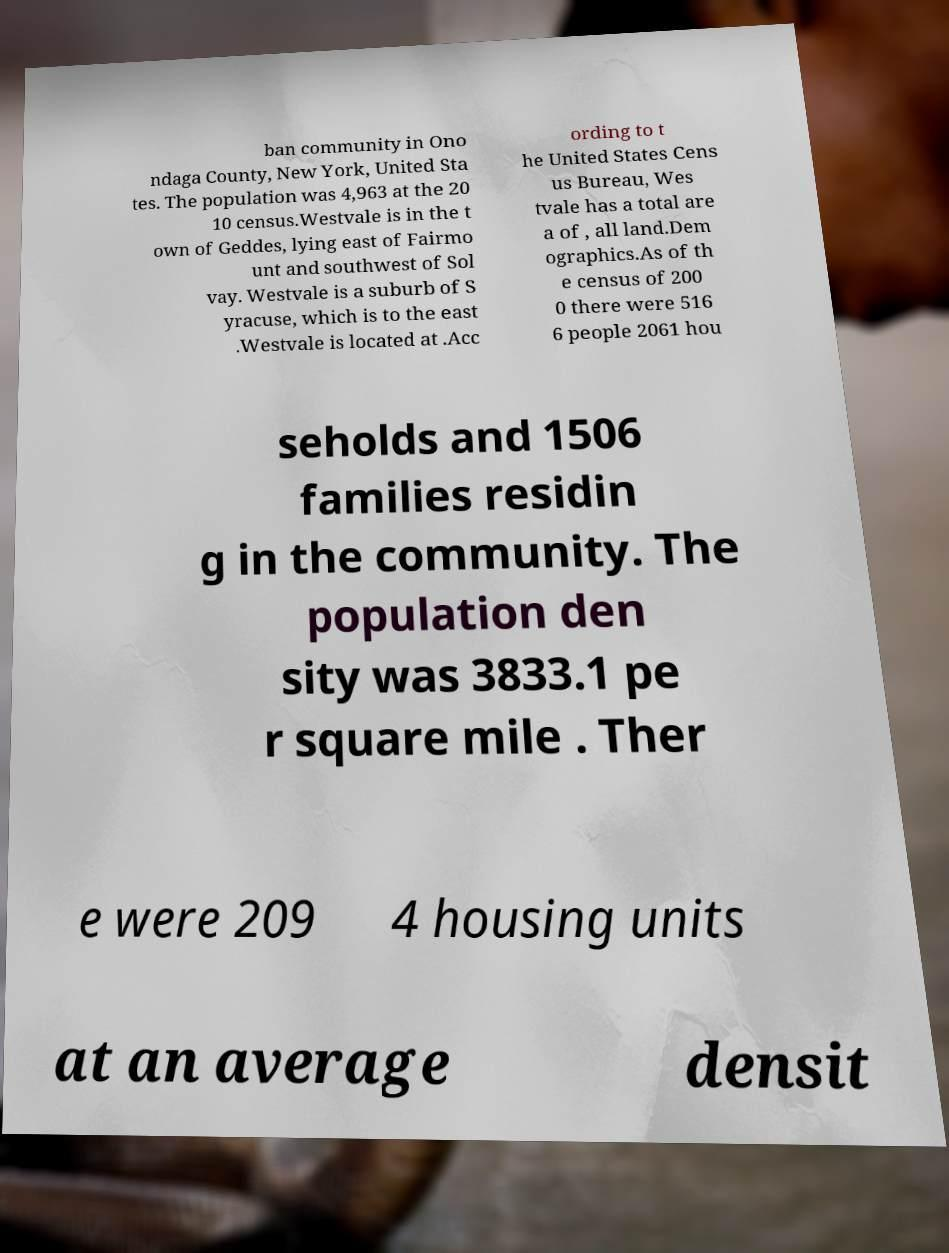Can you read and provide the text displayed in the image?This photo seems to have some interesting text. Can you extract and type it out for me? ban community in Ono ndaga County, New York, United Sta tes. The population was 4,963 at the 20 10 census.Westvale is in the t own of Geddes, lying east of Fairmo unt and southwest of Sol vay. Westvale is a suburb of S yracuse, which is to the east .Westvale is located at .Acc ording to t he United States Cens us Bureau, Wes tvale has a total are a of , all land.Dem ographics.As of th e census of 200 0 there were 516 6 people 2061 hou seholds and 1506 families residin g in the community. The population den sity was 3833.1 pe r square mile . Ther e were 209 4 housing units at an average densit 